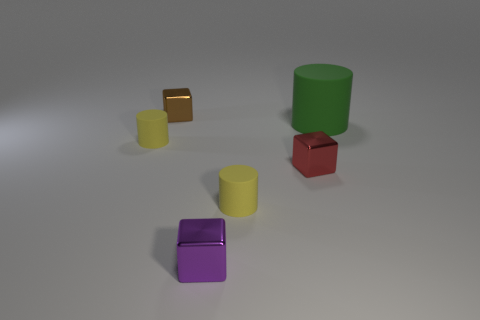Add 3 tiny yellow rubber cylinders. How many objects exist? 9 Add 2 tiny purple cubes. How many tiny purple cubes exist? 3 Subtract all yellow cylinders. How many cylinders are left? 1 Subtract all green cylinders. How many cylinders are left? 2 Subtract 0 green cubes. How many objects are left? 6 Subtract 1 cylinders. How many cylinders are left? 2 Subtract all yellow cylinders. Subtract all green balls. How many cylinders are left? 1 Subtract all gray cylinders. How many purple blocks are left? 1 Subtract all big green rubber things. Subtract all tiny brown spheres. How many objects are left? 5 Add 6 metallic things. How many metallic things are left? 9 